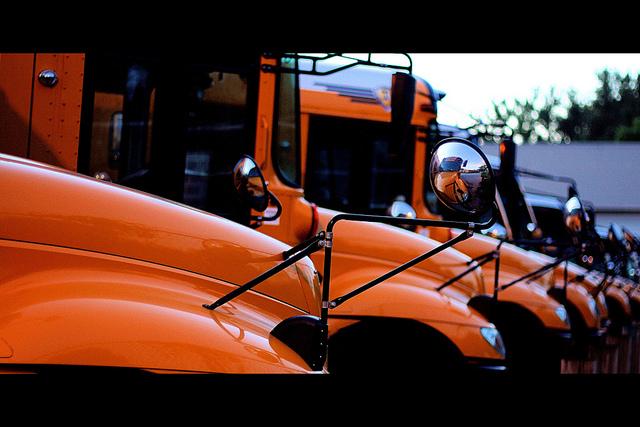Are any of the buses running?
Write a very short answer. No. What color is the bus?
Keep it brief. Orange. How many buses do you see?
Short answer required. 6. 